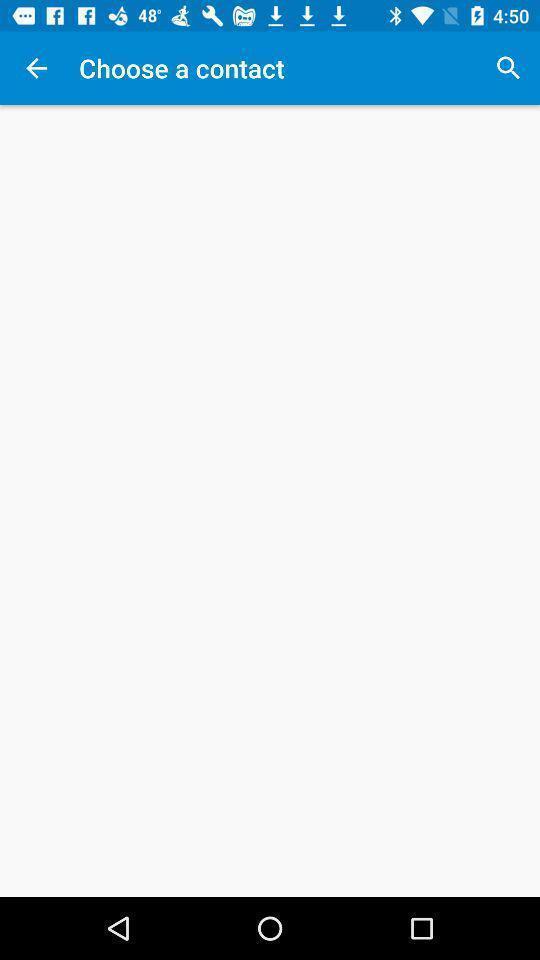Describe the visual elements of this screenshot. Page displaying information about selecting contact with search option. 